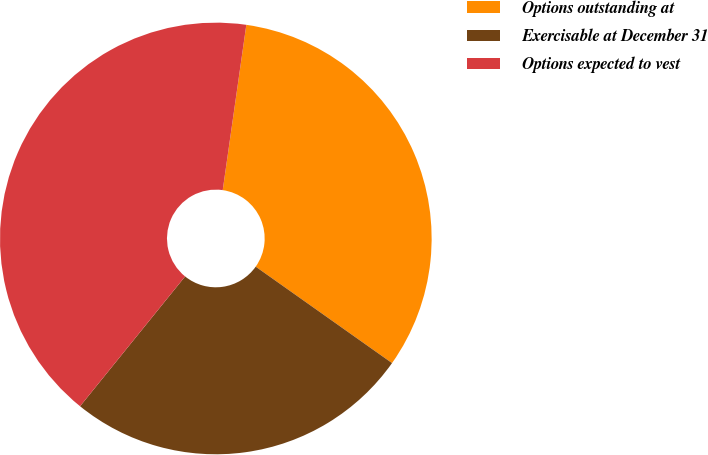Convert chart. <chart><loc_0><loc_0><loc_500><loc_500><pie_chart><fcel>Options outstanding at<fcel>Exercisable at December 31<fcel>Options expected to vest<nl><fcel>32.54%<fcel>26.03%<fcel>41.43%<nl></chart> 